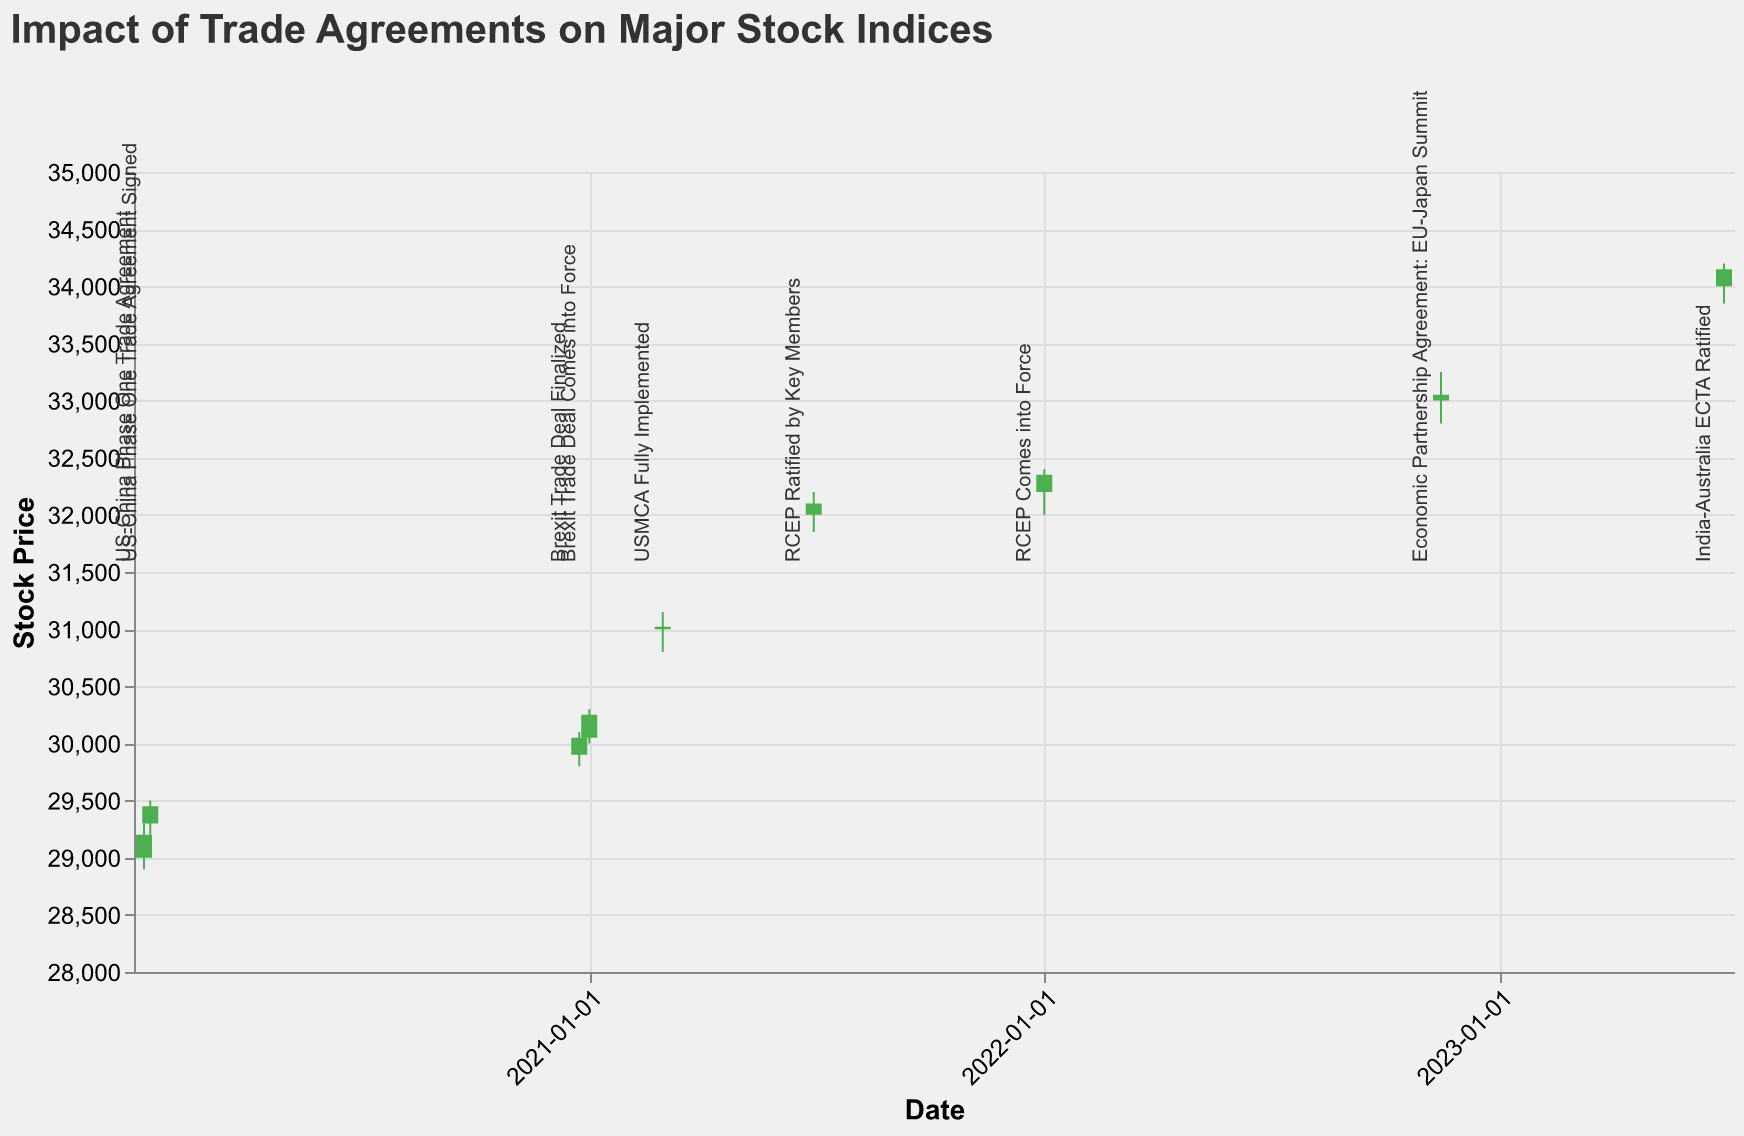What's the title of the chart? The chart's title is displayed at the top in a clear, larger font. It reads "Impact of Trade Agreements on Major Stock Indices."
Answer: Impact of Trade Agreements on Major Stock Indices What is the date with the highest stock price recorded? By observing the data points, the date on 2023-06-30 has the highest 'High' price recorded at 34200.
Answer: 2023-06-30 Which trade agreement dates showed a closing price higher than the opening price? To answer this, check the dates where green bars are present in the candlestick plot, indicating a closing price higher than the opening price. These dates are: 2020-01-10, 2020-01-15, 2020-12-24, 2021-01-01, 2021-03-01, 2021-06-30, 2022-01-01, 2023-06-30.
Answer: 2020-01-10, 2020-01-15, 2020-12-24, 2021-01-01, 2021-03-01, 2021-06-30, 2022-01-01, 2023-06-30 What is the average closing price of all the data points shown? Calculate the average by summing the closing prices (29200 + 29450 + 30050 + 30250 + 31020 + 32100 + 32350 + 33050 + 34150 = 281620) and dividing by the number of data points (9).
Answer: 31290 How does the stock price change after the Brexit Trade Deal Finalized on 2020-12-24 within the next week? Compare the closing price on 2020-12-24 (30050) and the closing price one week later on 2021-01-01 (30250). The price increased by 200.
Answer: Increase by 200 Which event had the highest trading volume? By examining the volumes, the highest volume recorded is 5.0M on 2022-11-15, associated with the "Economic Partnership Agreement: EU-Japan Summit".
Answer: Economic Partnership Agreement: EU-Japan Summit For the US-China Phase One Trade Agreement, what was the range of stock prices on 2020-01-10? The range can be calculated by taking the difference between the highest price (29300) and the lowest price (28900) on 2020-01-10. The range is 400.
Answer: 400 What can you infer about the stock trend before and after the India-Australia ECTA Ratified event on 2023-06-30? The stock price increased after the 2023-06-30 event. Compare the closing price before the event on 2022-11-15 (33050) and the closing price on 2023-06-30 (34150). The price shows an upward trend.
Answer: Upward trend What's the median volume of trades across all events? Arrange volumes in order: 3.5M, 3.8M, 3.9M, 4.0M, 4.1M, 4.2M, 4.3M, 4.5M, 5.0M. The median volume is the middle value in this ordered list, which is 4.1M.
Answer: 4.1M 